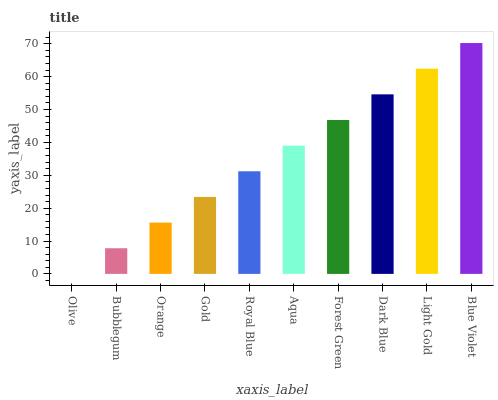Is Olive the minimum?
Answer yes or no. Yes. Is Blue Violet the maximum?
Answer yes or no. Yes. Is Bubblegum the minimum?
Answer yes or no. No. Is Bubblegum the maximum?
Answer yes or no. No. Is Bubblegum greater than Olive?
Answer yes or no. Yes. Is Olive less than Bubblegum?
Answer yes or no. Yes. Is Olive greater than Bubblegum?
Answer yes or no. No. Is Bubblegum less than Olive?
Answer yes or no. No. Is Aqua the high median?
Answer yes or no. Yes. Is Royal Blue the low median?
Answer yes or no. Yes. Is Forest Green the high median?
Answer yes or no. No. Is Orange the low median?
Answer yes or no. No. 